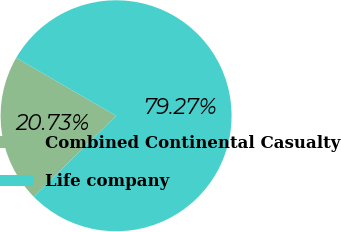<chart> <loc_0><loc_0><loc_500><loc_500><pie_chart><fcel>Combined Continental Casualty<fcel>Life company<nl><fcel>20.73%<fcel>79.27%<nl></chart> 